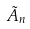Convert formula to latex. <formula><loc_0><loc_0><loc_500><loc_500>\tilde { A } _ { n }</formula> 